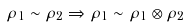Convert formula to latex. <formula><loc_0><loc_0><loc_500><loc_500>\rho _ { 1 } \sim \rho _ { 2 } \Rightarrow \rho _ { 1 } \sim \rho _ { 1 } \otimes \rho _ { 2 }</formula> 